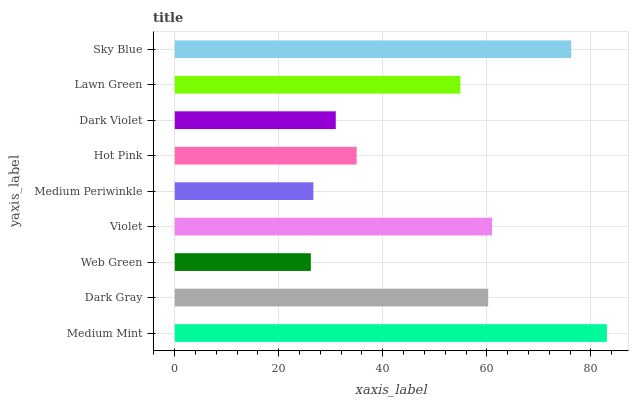Is Web Green the minimum?
Answer yes or no. Yes. Is Medium Mint the maximum?
Answer yes or no. Yes. Is Dark Gray the minimum?
Answer yes or no. No. Is Dark Gray the maximum?
Answer yes or no. No. Is Medium Mint greater than Dark Gray?
Answer yes or no. Yes. Is Dark Gray less than Medium Mint?
Answer yes or no. Yes. Is Dark Gray greater than Medium Mint?
Answer yes or no. No. Is Medium Mint less than Dark Gray?
Answer yes or no. No. Is Lawn Green the high median?
Answer yes or no. Yes. Is Lawn Green the low median?
Answer yes or no. Yes. Is Dark Violet the high median?
Answer yes or no. No. Is Sky Blue the low median?
Answer yes or no. No. 